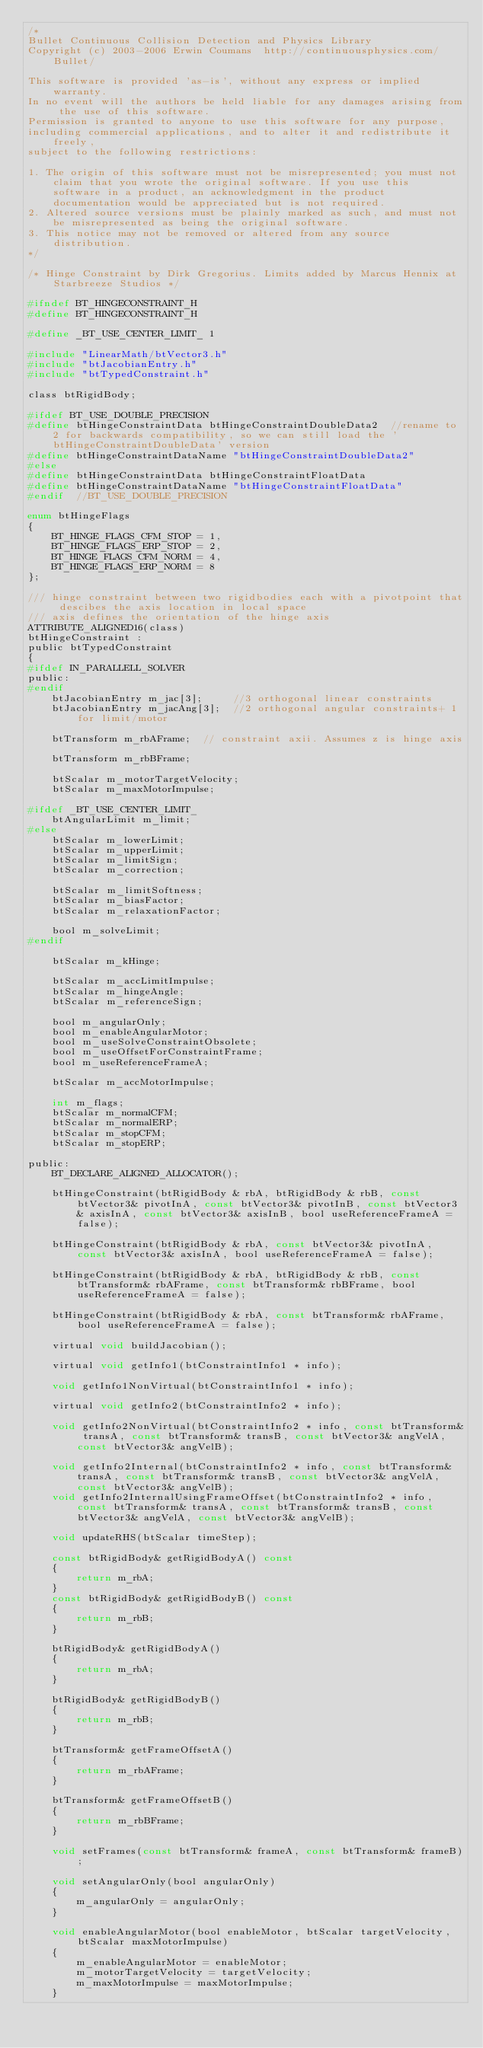Convert code to text. <code><loc_0><loc_0><loc_500><loc_500><_C_>/*
Bullet Continuous Collision Detection and Physics Library
Copyright (c) 2003-2006 Erwin Coumans  http://continuousphysics.com/Bullet/

This software is provided 'as-is', without any express or implied warranty.
In no event will the authors be held liable for any damages arising from the use of this software.
Permission is granted to anyone to use this software for any purpose,
including commercial applications, and to alter it and redistribute it freely,
subject to the following restrictions:

1. The origin of this software must not be misrepresented; you must not claim that you wrote the original software. If you use this software in a product, an acknowledgment in the product documentation would be appreciated but is not required.
2. Altered source versions must be plainly marked as such, and must not be misrepresented as being the original software.
3. This notice may not be removed or altered from any source distribution.
*/

/* Hinge Constraint by Dirk Gregorius. Limits added by Marcus Hennix at Starbreeze Studios */

#ifndef BT_HINGECONSTRAINT_H
#define BT_HINGECONSTRAINT_H

#define _BT_USE_CENTER_LIMIT_ 1

#include "LinearMath/btVector3.h"
#include "btJacobianEntry.h"
#include "btTypedConstraint.h"

class btRigidBody;

#ifdef BT_USE_DOUBLE_PRECISION
#define btHingeConstraintData btHingeConstraintDoubleData2  //rename to 2 for backwards compatibility, so we can still load the 'btHingeConstraintDoubleData' version
#define btHingeConstraintDataName "btHingeConstraintDoubleData2"
#else
#define btHingeConstraintData btHingeConstraintFloatData
#define btHingeConstraintDataName "btHingeConstraintFloatData"
#endif  //BT_USE_DOUBLE_PRECISION

enum btHingeFlags
{
	BT_HINGE_FLAGS_CFM_STOP = 1,
	BT_HINGE_FLAGS_ERP_STOP = 2,
	BT_HINGE_FLAGS_CFM_NORM = 4,
	BT_HINGE_FLAGS_ERP_NORM = 8
};

/// hinge constraint between two rigidbodies each with a pivotpoint that descibes the axis location in local space
/// axis defines the orientation of the hinge axis
ATTRIBUTE_ALIGNED16(class)
btHingeConstraint :
public btTypedConstraint
{
#ifdef IN_PARALLELL_SOLVER
public:
#endif
	btJacobianEntry m_jac[3];     //3 orthogonal linear constraints
	btJacobianEntry m_jacAng[3];  //2 orthogonal angular constraints+ 1 for limit/motor

	btTransform m_rbAFrame;  // constraint axii. Assumes z is hinge axis.
	btTransform m_rbBFrame;

	btScalar m_motorTargetVelocity;
	btScalar m_maxMotorImpulse;

#ifdef _BT_USE_CENTER_LIMIT_
	btAngularLimit m_limit;
#else
	btScalar m_lowerLimit;
	btScalar m_upperLimit;
	btScalar m_limitSign;
	btScalar m_correction;

	btScalar m_limitSoftness;
	btScalar m_biasFactor;
	btScalar m_relaxationFactor;

	bool m_solveLimit;
#endif

	btScalar m_kHinge;

	btScalar m_accLimitImpulse;
	btScalar m_hingeAngle;
	btScalar m_referenceSign;

	bool m_angularOnly;
	bool m_enableAngularMotor;
	bool m_useSolveConstraintObsolete;
	bool m_useOffsetForConstraintFrame;
	bool m_useReferenceFrameA;

	btScalar m_accMotorImpulse;

	int m_flags;
	btScalar m_normalCFM;
	btScalar m_normalERP;
	btScalar m_stopCFM;
	btScalar m_stopERP;

public:
	BT_DECLARE_ALIGNED_ALLOCATOR();

	btHingeConstraint(btRigidBody & rbA, btRigidBody & rbB, const btVector3& pivotInA, const btVector3& pivotInB, const btVector3& axisInA, const btVector3& axisInB, bool useReferenceFrameA = false);

	btHingeConstraint(btRigidBody & rbA, const btVector3& pivotInA, const btVector3& axisInA, bool useReferenceFrameA = false);

	btHingeConstraint(btRigidBody & rbA, btRigidBody & rbB, const btTransform& rbAFrame, const btTransform& rbBFrame, bool useReferenceFrameA = false);

	btHingeConstraint(btRigidBody & rbA, const btTransform& rbAFrame, bool useReferenceFrameA = false);

	virtual void buildJacobian();

	virtual void getInfo1(btConstraintInfo1 * info);

	void getInfo1NonVirtual(btConstraintInfo1 * info);

	virtual void getInfo2(btConstraintInfo2 * info);

	void getInfo2NonVirtual(btConstraintInfo2 * info, const btTransform& transA, const btTransform& transB, const btVector3& angVelA, const btVector3& angVelB);

	void getInfo2Internal(btConstraintInfo2 * info, const btTransform& transA, const btTransform& transB, const btVector3& angVelA, const btVector3& angVelB);
	void getInfo2InternalUsingFrameOffset(btConstraintInfo2 * info, const btTransform& transA, const btTransform& transB, const btVector3& angVelA, const btVector3& angVelB);

	void updateRHS(btScalar timeStep);

	const btRigidBody& getRigidBodyA() const
	{
		return m_rbA;
	}
	const btRigidBody& getRigidBodyB() const
	{
		return m_rbB;
	}

	btRigidBody& getRigidBodyA()
	{
		return m_rbA;
	}

	btRigidBody& getRigidBodyB()
	{
		return m_rbB;
	}

	btTransform& getFrameOffsetA()
	{
		return m_rbAFrame;
	}

	btTransform& getFrameOffsetB()
	{
		return m_rbBFrame;
	}

	void setFrames(const btTransform& frameA, const btTransform& frameB);

	void setAngularOnly(bool angularOnly)
	{
		m_angularOnly = angularOnly;
	}

	void enableAngularMotor(bool enableMotor, btScalar targetVelocity, btScalar maxMotorImpulse)
	{
		m_enableAngularMotor = enableMotor;
		m_motorTargetVelocity = targetVelocity;
		m_maxMotorImpulse = maxMotorImpulse;
	}
</code> 